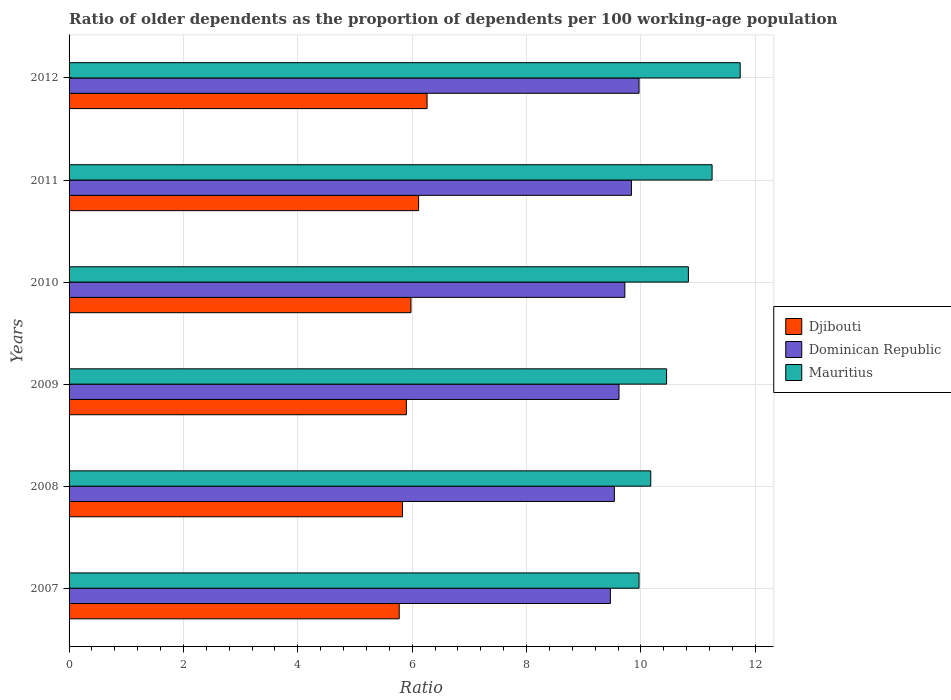How many groups of bars are there?
Ensure brevity in your answer.  6. Are the number of bars on each tick of the Y-axis equal?
Give a very brief answer. Yes. What is the age dependency ratio(old) in Djibouti in 2009?
Offer a very short reply. 5.9. Across all years, what is the maximum age dependency ratio(old) in Mauritius?
Your answer should be compact. 11.74. Across all years, what is the minimum age dependency ratio(old) in Mauritius?
Keep it short and to the point. 9.97. In which year was the age dependency ratio(old) in Mauritius maximum?
Give a very brief answer. 2012. In which year was the age dependency ratio(old) in Djibouti minimum?
Your response must be concise. 2007. What is the total age dependency ratio(old) in Dominican Republic in the graph?
Make the answer very short. 58.14. What is the difference between the age dependency ratio(old) in Dominican Republic in 2007 and that in 2011?
Provide a succinct answer. -0.37. What is the difference between the age dependency ratio(old) in Dominican Republic in 2008 and the age dependency ratio(old) in Mauritius in 2007?
Your response must be concise. -0.43. What is the average age dependency ratio(old) in Dominican Republic per year?
Ensure brevity in your answer.  9.69. In the year 2007, what is the difference between the age dependency ratio(old) in Djibouti and age dependency ratio(old) in Mauritius?
Ensure brevity in your answer.  -4.19. What is the ratio of the age dependency ratio(old) in Mauritius in 2009 to that in 2010?
Offer a terse response. 0.96. What is the difference between the highest and the second highest age dependency ratio(old) in Djibouti?
Keep it short and to the point. 0.15. What is the difference between the highest and the lowest age dependency ratio(old) in Mauritius?
Make the answer very short. 1.77. In how many years, is the age dependency ratio(old) in Djibouti greater than the average age dependency ratio(old) in Djibouti taken over all years?
Your answer should be very brief. 3. Is the sum of the age dependency ratio(old) in Djibouti in 2008 and 2012 greater than the maximum age dependency ratio(old) in Dominican Republic across all years?
Keep it short and to the point. Yes. What does the 1st bar from the top in 2009 represents?
Your answer should be compact. Mauritius. What does the 3rd bar from the bottom in 2010 represents?
Offer a terse response. Mauritius. Are all the bars in the graph horizontal?
Make the answer very short. Yes. How many years are there in the graph?
Offer a terse response. 6. What is the difference between two consecutive major ticks on the X-axis?
Keep it short and to the point. 2. Where does the legend appear in the graph?
Your answer should be compact. Center right. How many legend labels are there?
Give a very brief answer. 3. How are the legend labels stacked?
Offer a very short reply. Vertical. What is the title of the graph?
Make the answer very short. Ratio of older dependents as the proportion of dependents per 100 working-age population. What is the label or title of the X-axis?
Offer a very short reply. Ratio. What is the Ratio in Djibouti in 2007?
Your answer should be compact. 5.77. What is the Ratio of Dominican Republic in 2007?
Offer a terse response. 9.47. What is the Ratio in Mauritius in 2007?
Offer a terse response. 9.97. What is the Ratio in Djibouti in 2008?
Your answer should be very brief. 5.83. What is the Ratio of Dominican Republic in 2008?
Ensure brevity in your answer.  9.54. What is the Ratio of Mauritius in 2008?
Provide a short and direct response. 10.17. What is the Ratio in Djibouti in 2009?
Offer a very short reply. 5.9. What is the Ratio in Dominican Republic in 2009?
Your response must be concise. 9.62. What is the Ratio in Mauritius in 2009?
Your response must be concise. 10.45. What is the Ratio of Djibouti in 2010?
Keep it short and to the point. 5.98. What is the Ratio of Dominican Republic in 2010?
Offer a terse response. 9.72. What is the Ratio in Mauritius in 2010?
Offer a terse response. 10.83. What is the Ratio of Djibouti in 2011?
Your answer should be compact. 6.11. What is the Ratio in Dominican Republic in 2011?
Give a very brief answer. 9.83. What is the Ratio of Mauritius in 2011?
Keep it short and to the point. 11.24. What is the Ratio of Djibouti in 2012?
Your answer should be compact. 6.26. What is the Ratio of Dominican Republic in 2012?
Provide a short and direct response. 9.97. What is the Ratio of Mauritius in 2012?
Your response must be concise. 11.74. Across all years, what is the maximum Ratio of Djibouti?
Offer a very short reply. 6.26. Across all years, what is the maximum Ratio of Dominican Republic?
Offer a terse response. 9.97. Across all years, what is the maximum Ratio of Mauritius?
Provide a succinct answer. 11.74. Across all years, what is the minimum Ratio of Djibouti?
Provide a succinct answer. 5.77. Across all years, what is the minimum Ratio in Dominican Republic?
Your answer should be very brief. 9.47. Across all years, what is the minimum Ratio of Mauritius?
Your response must be concise. 9.97. What is the total Ratio of Djibouti in the graph?
Make the answer very short. 35.85. What is the total Ratio of Dominican Republic in the graph?
Keep it short and to the point. 58.14. What is the total Ratio of Mauritius in the graph?
Give a very brief answer. 64.4. What is the difference between the Ratio in Djibouti in 2007 and that in 2008?
Provide a short and direct response. -0.06. What is the difference between the Ratio of Dominican Republic in 2007 and that in 2008?
Your answer should be compact. -0.07. What is the difference between the Ratio in Mauritius in 2007 and that in 2008?
Ensure brevity in your answer.  -0.21. What is the difference between the Ratio in Djibouti in 2007 and that in 2009?
Provide a short and direct response. -0.13. What is the difference between the Ratio in Dominican Republic in 2007 and that in 2009?
Your response must be concise. -0.15. What is the difference between the Ratio of Mauritius in 2007 and that in 2009?
Your answer should be compact. -0.48. What is the difference between the Ratio in Djibouti in 2007 and that in 2010?
Keep it short and to the point. -0.21. What is the difference between the Ratio of Dominican Republic in 2007 and that in 2010?
Offer a very short reply. -0.25. What is the difference between the Ratio in Mauritius in 2007 and that in 2010?
Provide a short and direct response. -0.86. What is the difference between the Ratio in Djibouti in 2007 and that in 2011?
Offer a very short reply. -0.34. What is the difference between the Ratio of Dominican Republic in 2007 and that in 2011?
Make the answer very short. -0.37. What is the difference between the Ratio in Mauritius in 2007 and that in 2011?
Make the answer very short. -1.28. What is the difference between the Ratio in Djibouti in 2007 and that in 2012?
Provide a succinct answer. -0.49. What is the difference between the Ratio of Dominican Republic in 2007 and that in 2012?
Your answer should be compact. -0.5. What is the difference between the Ratio of Mauritius in 2007 and that in 2012?
Your answer should be compact. -1.77. What is the difference between the Ratio of Djibouti in 2008 and that in 2009?
Offer a very short reply. -0.07. What is the difference between the Ratio in Dominican Republic in 2008 and that in 2009?
Ensure brevity in your answer.  -0.08. What is the difference between the Ratio of Mauritius in 2008 and that in 2009?
Provide a short and direct response. -0.28. What is the difference between the Ratio in Djibouti in 2008 and that in 2010?
Offer a terse response. -0.15. What is the difference between the Ratio in Dominican Republic in 2008 and that in 2010?
Ensure brevity in your answer.  -0.18. What is the difference between the Ratio of Mauritius in 2008 and that in 2010?
Offer a terse response. -0.66. What is the difference between the Ratio in Djibouti in 2008 and that in 2011?
Provide a succinct answer. -0.28. What is the difference between the Ratio in Dominican Republic in 2008 and that in 2011?
Provide a succinct answer. -0.3. What is the difference between the Ratio in Mauritius in 2008 and that in 2011?
Provide a succinct answer. -1.07. What is the difference between the Ratio in Djibouti in 2008 and that in 2012?
Provide a succinct answer. -0.43. What is the difference between the Ratio in Dominican Republic in 2008 and that in 2012?
Ensure brevity in your answer.  -0.43. What is the difference between the Ratio of Mauritius in 2008 and that in 2012?
Provide a succinct answer. -1.56. What is the difference between the Ratio of Djibouti in 2009 and that in 2010?
Provide a short and direct response. -0.08. What is the difference between the Ratio of Dominican Republic in 2009 and that in 2010?
Provide a succinct answer. -0.1. What is the difference between the Ratio of Mauritius in 2009 and that in 2010?
Your response must be concise. -0.38. What is the difference between the Ratio of Djibouti in 2009 and that in 2011?
Provide a succinct answer. -0.21. What is the difference between the Ratio in Dominican Republic in 2009 and that in 2011?
Make the answer very short. -0.22. What is the difference between the Ratio in Mauritius in 2009 and that in 2011?
Offer a terse response. -0.8. What is the difference between the Ratio in Djibouti in 2009 and that in 2012?
Keep it short and to the point. -0.36. What is the difference between the Ratio in Dominican Republic in 2009 and that in 2012?
Provide a short and direct response. -0.35. What is the difference between the Ratio of Mauritius in 2009 and that in 2012?
Your response must be concise. -1.29. What is the difference between the Ratio in Djibouti in 2010 and that in 2011?
Offer a very short reply. -0.13. What is the difference between the Ratio in Dominican Republic in 2010 and that in 2011?
Keep it short and to the point. -0.12. What is the difference between the Ratio in Mauritius in 2010 and that in 2011?
Your answer should be very brief. -0.41. What is the difference between the Ratio of Djibouti in 2010 and that in 2012?
Offer a very short reply. -0.28. What is the difference between the Ratio of Dominican Republic in 2010 and that in 2012?
Your answer should be compact. -0.25. What is the difference between the Ratio of Mauritius in 2010 and that in 2012?
Ensure brevity in your answer.  -0.91. What is the difference between the Ratio of Djibouti in 2011 and that in 2012?
Offer a terse response. -0.15. What is the difference between the Ratio of Dominican Republic in 2011 and that in 2012?
Give a very brief answer. -0.13. What is the difference between the Ratio of Mauritius in 2011 and that in 2012?
Your answer should be very brief. -0.49. What is the difference between the Ratio of Djibouti in 2007 and the Ratio of Dominican Republic in 2008?
Provide a succinct answer. -3.76. What is the difference between the Ratio in Djibouti in 2007 and the Ratio in Mauritius in 2008?
Keep it short and to the point. -4.4. What is the difference between the Ratio in Dominican Republic in 2007 and the Ratio in Mauritius in 2008?
Provide a succinct answer. -0.71. What is the difference between the Ratio in Djibouti in 2007 and the Ratio in Dominican Republic in 2009?
Provide a succinct answer. -3.84. What is the difference between the Ratio of Djibouti in 2007 and the Ratio of Mauritius in 2009?
Offer a terse response. -4.68. What is the difference between the Ratio of Dominican Republic in 2007 and the Ratio of Mauritius in 2009?
Provide a short and direct response. -0.98. What is the difference between the Ratio in Djibouti in 2007 and the Ratio in Dominican Republic in 2010?
Offer a very short reply. -3.95. What is the difference between the Ratio of Djibouti in 2007 and the Ratio of Mauritius in 2010?
Your response must be concise. -5.06. What is the difference between the Ratio of Dominican Republic in 2007 and the Ratio of Mauritius in 2010?
Keep it short and to the point. -1.36. What is the difference between the Ratio of Djibouti in 2007 and the Ratio of Dominican Republic in 2011?
Give a very brief answer. -4.06. What is the difference between the Ratio in Djibouti in 2007 and the Ratio in Mauritius in 2011?
Your response must be concise. -5.47. What is the difference between the Ratio of Dominican Republic in 2007 and the Ratio of Mauritius in 2011?
Your answer should be compact. -1.78. What is the difference between the Ratio of Djibouti in 2007 and the Ratio of Dominican Republic in 2012?
Make the answer very short. -4.19. What is the difference between the Ratio of Djibouti in 2007 and the Ratio of Mauritius in 2012?
Give a very brief answer. -5.96. What is the difference between the Ratio of Dominican Republic in 2007 and the Ratio of Mauritius in 2012?
Give a very brief answer. -2.27. What is the difference between the Ratio of Djibouti in 2008 and the Ratio of Dominican Republic in 2009?
Provide a succinct answer. -3.79. What is the difference between the Ratio of Djibouti in 2008 and the Ratio of Mauritius in 2009?
Keep it short and to the point. -4.62. What is the difference between the Ratio in Dominican Republic in 2008 and the Ratio in Mauritius in 2009?
Keep it short and to the point. -0.91. What is the difference between the Ratio of Djibouti in 2008 and the Ratio of Dominican Republic in 2010?
Keep it short and to the point. -3.89. What is the difference between the Ratio in Djibouti in 2008 and the Ratio in Mauritius in 2010?
Make the answer very short. -5. What is the difference between the Ratio of Dominican Republic in 2008 and the Ratio of Mauritius in 2010?
Give a very brief answer. -1.29. What is the difference between the Ratio of Djibouti in 2008 and the Ratio of Dominican Republic in 2011?
Your answer should be compact. -4. What is the difference between the Ratio of Djibouti in 2008 and the Ratio of Mauritius in 2011?
Your response must be concise. -5.41. What is the difference between the Ratio of Dominican Republic in 2008 and the Ratio of Mauritius in 2011?
Ensure brevity in your answer.  -1.71. What is the difference between the Ratio of Djibouti in 2008 and the Ratio of Dominican Republic in 2012?
Provide a succinct answer. -4.14. What is the difference between the Ratio of Djibouti in 2008 and the Ratio of Mauritius in 2012?
Provide a succinct answer. -5.9. What is the difference between the Ratio in Dominican Republic in 2008 and the Ratio in Mauritius in 2012?
Keep it short and to the point. -2.2. What is the difference between the Ratio of Djibouti in 2009 and the Ratio of Dominican Republic in 2010?
Your answer should be compact. -3.82. What is the difference between the Ratio in Djibouti in 2009 and the Ratio in Mauritius in 2010?
Make the answer very short. -4.93. What is the difference between the Ratio in Dominican Republic in 2009 and the Ratio in Mauritius in 2010?
Offer a terse response. -1.21. What is the difference between the Ratio of Djibouti in 2009 and the Ratio of Dominican Republic in 2011?
Your answer should be compact. -3.94. What is the difference between the Ratio of Djibouti in 2009 and the Ratio of Mauritius in 2011?
Your answer should be compact. -5.35. What is the difference between the Ratio of Dominican Republic in 2009 and the Ratio of Mauritius in 2011?
Your response must be concise. -1.63. What is the difference between the Ratio in Djibouti in 2009 and the Ratio in Dominican Republic in 2012?
Make the answer very short. -4.07. What is the difference between the Ratio of Djibouti in 2009 and the Ratio of Mauritius in 2012?
Ensure brevity in your answer.  -5.84. What is the difference between the Ratio in Dominican Republic in 2009 and the Ratio in Mauritius in 2012?
Your answer should be very brief. -2.12. What is the difference between the Ratio of Djibouti in 2010 and the Ratio of Dominican Republic in 2011?
Offer a very short reply. -3.86. What is the difference between the Ratio in Djibouti in 2010 and the Ratio in Mauritius in 2011?
Keep it short and to the point. -5.27. What is the difference between the Ratio of Dominican Republic in 2010 and the Ratio of Mauritius in 2011?
Your answer should be compact. -1.53. What is the difference between the Ratio of Djibouti in 2010 and the Ratio of Dominican Republic in 2012?
Ensure brevity in your answer.  -3.99. What is the difference between the Ratio in Djibouti in 2010 and the Ratio in Mauritius in 2012?
Keep it short and to the point. -5.76. What is the difference between the Ratio in Dominican Republic in 2010 and the Ratio in Mauritius in 2012?
Ensure brevity in your answer.  -2.02. What is the difference between the Ratio in Djibouti in 2011 and the Ratio in Dominican Republic in 2012?
Give a very brief answer. -3.85. What is the difference between the Ratio of Djibouti in 2011 and the Ratio of Mauritius in 2012?
Provide a succinct answer. -5.62. What is the difference between the Ratio in Dominican Republic in 2011 and the Ratio in Mauritius in 2012?
Provide a succinct answer. -1.9. What is the average Ratio of Djibouti per year?
Provide a succinct answer. 5.98. What is the average Ratio in Dominican Republic per year?
Offer a terse response. 9.69. What is the average Ratio in Mauritius per year?
Your answer should be compact. 10.73. In the year 2007, what is the difference between the Ratio in Djibouti and Ratio in Dominican Republic?
Provide a short and direct response. -3.69. In the year 2007, what is the difference between the Ratio in Djibouti and Ratio in Mauritius?
Ensure brevity in your answer.  -4.19. In the year 2007, what is the difference between the Ratio in Dominican Republic and Ratio in Mauritius?
Keep it short and to the point. -0.5. In the year 2008, what is the difference between the Ratio in Djibouti and Ratio in Dominican Republic?
Offer a very short reply. -3.7. In the year 2008, what is the difference between the Ratio of Djibouti and Ratio of Mauritius?
Offer a terse response. -4.34. In the year 2008, what is the difference between the Ratio of Dominican Republic and Ratio of Mauritius?
Offer a terse response. -0.64. In the year 2009, what is the difference between the Ratio in Djibouti and Ratio in Dominican Republic?
Provide a succinct answer. -3.72. In the year 2009, what is the difference between the Ratio of Djibouti and Ratio of Mauritius?
Offer a very short reply. -4.55. In the year 2009, what is the difference between the Ratio in Dominican Republic and Ratio in Mauritius?
Keep it short and to the point. -0.83. In the year 2010, what is the difference between the Ratio of Djibouti and Ratio of Dominican Republic?
Keep it short and to the point. -3.74. In the year 2010, what is the difference between the Ratio in Djibouti and Ratio in Mauritius?
Your response must be concise. -4.85. In the year 2010, what is the difference between the Ratio of Dominican Republic and Ratio of Mauritius?
Make the answer very short. -1.11. In the year 2011, what is the difference between the Ratio in Djibouti and Ratio in Dominican Republic?
Provide a succinct answer. -3.72. In the year 2011, what is the difference between the Ratio of Djibouti and Ratio of Mauritius?
Give a very brief answer. -5.13. In the year 2011, what is the difference between the Ratio in Dominican Republic and Ratio in Mauritius?
Offer a terse response. -1.41. In the year 2012, what is the difference between the Ratio of Djibouti and Ratio of Dominican Republic?
Provide a succinct answer. -3.71. In the year 2012, what is the difference between the Ratio of Djibouti and Ratio of Mauritius?
Make the answer very short. -5.48. In the year 2012, what is the difference between the Ratio in Dominican Republic and Ratio in Mauritius?
Give a very brief answer. -1.77. What is the ratio of the Ratio in Djibouti in 2007 to that in 2008?
Offer a terse response. 0.99. What is the ratio of the Ratio in Dominican Republic in 2007 to that in 2008?
Your answer should be very brief. 0.99. What is the ratio of the Ratio of Mauritius in 2007 to that in 2008?
Make the answer very short. 0.98. What is the ratio of the Ratio in Djibouti in 2007 to that in 2009?
Give a very brief answer. 0.98. What is the ratio of the Ratio in Dominican Republic in 2007 to that in 2009?
Offer a very short reply. 0.98. What is the ratio of the Ratio of Mauritius in 2007 to that in 2009?
Provide a succinct answer. 0.95. What is the ratio of the Ratio of Djibouti in 2007 to that in 2010?
Offer a terse response. 0.97. What is the ratio of the Ratio in Dominican Republic in 2007 to that in 2010?
Provide a short and direct response. 0.97. What is the ratio of the Ratio of Mauritius in 2007 to that in 2010?
Your answer should be very brief. 0.92. What is the ratio of the Ratio in Djibouti in 2007 to that in 2011?
Offer a terse response. 0.94. What is the ratio of the Ratio of Dominican Republic in 2007 to that in 2011?
Ensure brevity in your answer.  0.96. What is the ratio of the Ratio in Mauritius in 2007 to that in 2011?
Your answer should be compact. 0.89. What is the ratio of the Ratio in Djibouti in 2007 to that in 2012?
Ensure brevity in your answer.  0.92. What is the ratio of the Ratio in Dominican Republic in 2007 to that in 2012?
Offer a very short reply. 0.95. What is the ratio of the Ratio in Mauritius in 2007 to that in 2012?
Offer a very short reply. 0.85. What is the ratio of the Ratio of Djibouti in 2008 to that in 2009?
Make the answer very short. 0.99. What is the ratio of the Ratio of Mauritius in 2008 to that in 2009?
Your answer should be very brief. 0.97. What is the ratio of the Ratio of Djibouti in 2008 to that in 2010?
Your response must be concise. 0.98. What is the ratio of the Ratio of Dominican Republic in 2008 to that in 2010?
Make the answer very short. 0.98. What is the ratio of the Ratio in Mauritius in 2008 to that in 2010?
Make the answer very short. 0.94. What is the ratio of the Ratio in Djibouti in 2008 to that in 2011?
Make the answer very short. 0.95. What is the ratio of the Ratio in Dominican Republic in 2008 to that in 2011?
Offer a very short reply. 0.97. What is the ratio of the Ratio of Mauritius in 2008 to that in 2011?
Provide a short and direct response. 0.9. What is the ratio of the Ratio in Djibouti in 2008 to that in 2012?
Ensure brevity in your answer.  0.93. What is the ratio of the Ratio in Dominican Republic in 2008 to that in 2012?
Offer a terse response. 0.96. What is the ratio of the Ratio in Mauritius in 2008 to that in 2012?
Offer a very short reply. 0.87. What is the ratio of the Ratio in Djibouti in 2009 to that in 2010?
Offer a terse response. 0.99. What is the ratio of the Ratio in Mauritius in 2009 to that in 2010?
Offer a terse response. 0.96. What is the ratio of the Ratio of Djibouti in 2009 to that in 2011?
Provide a short and direct response. 0.96. What is the ratio of the Ratio in Dominican Republic in 2009 to that in 2011?
Make the answer very short. 0.98. What is the ratio of the Ratio of Mauritius in 2009 to that in 2011?
Your answer should be compact. 0.93. What is the ratio of the Ratio in Djibouti in 2009 to that in 2012?
Your response must be concise. 0.94. What is the ratio of the Ratio in Dominican Republic in 2009 to that in 2012?
Offer a very short reply. 0.96. What is the ratio of the Ratio of Mauritius in 2009 to that in 2012?
Your response must be concise. 0.89. What is the ratio of the Ratio of Djibouti in 2010 to that in 2011?
Your response must be concise. 0.98. What is the ratio of the Ratio in Dominican Republic in 2010 to that in 2011?
Give a very brief answer. 0.99. What is the ratio of the Ratio in Mauritius in 2010 to that in 2011?
Provide a succinct answer. 0.96. What is the ratio of the Ratio in Djibouti in 2010 to that in 2012?
Give a very brief answer. 0.95. What is the ratio of the Ratio of Dominican Republic in 2010 to that in 2012?
Provide a short and direct response. 0.98. What is the ratio of the Ratio in Mauritius in 2010 to that in 2012?
Provide a short and direct response. 0.92. What is the ratio of the Ratio in Djibouti in 2011 to that in 2012?
Ensure brevity in your answer.  0.98. What is the ratio of the Ratio in Dominican Republic in 2011 to that in 2012?
Keep it short and to the point. 0.99. What is the ratio of the Ratio of Mauritius in 2011 to that in 2012?
Your response must be concise. 0.96. What is the difference between the highest and the second highest Ratio of Djibouti?
Ensure brevity in your answer.  0.15. What is the difference between the highest and the second highest Ratio of Dominican Republic?
Make the answer very short. 0.13. What is the difference between the highest and the second highest Ratio in Mauritius?
Your response must be concise. 0.49. What is the difference between the highest and the lowest Ratio of Djibouti?
Ensure brevity in your answer.  0.49. What is the difference between the highest and the lowest Ratio of Dominican Republic?
Your response must be concise. 0.5. What is the difference between the highest and the lowest Ratio in Mauritius?
Your answer should be compact. 1.77. 